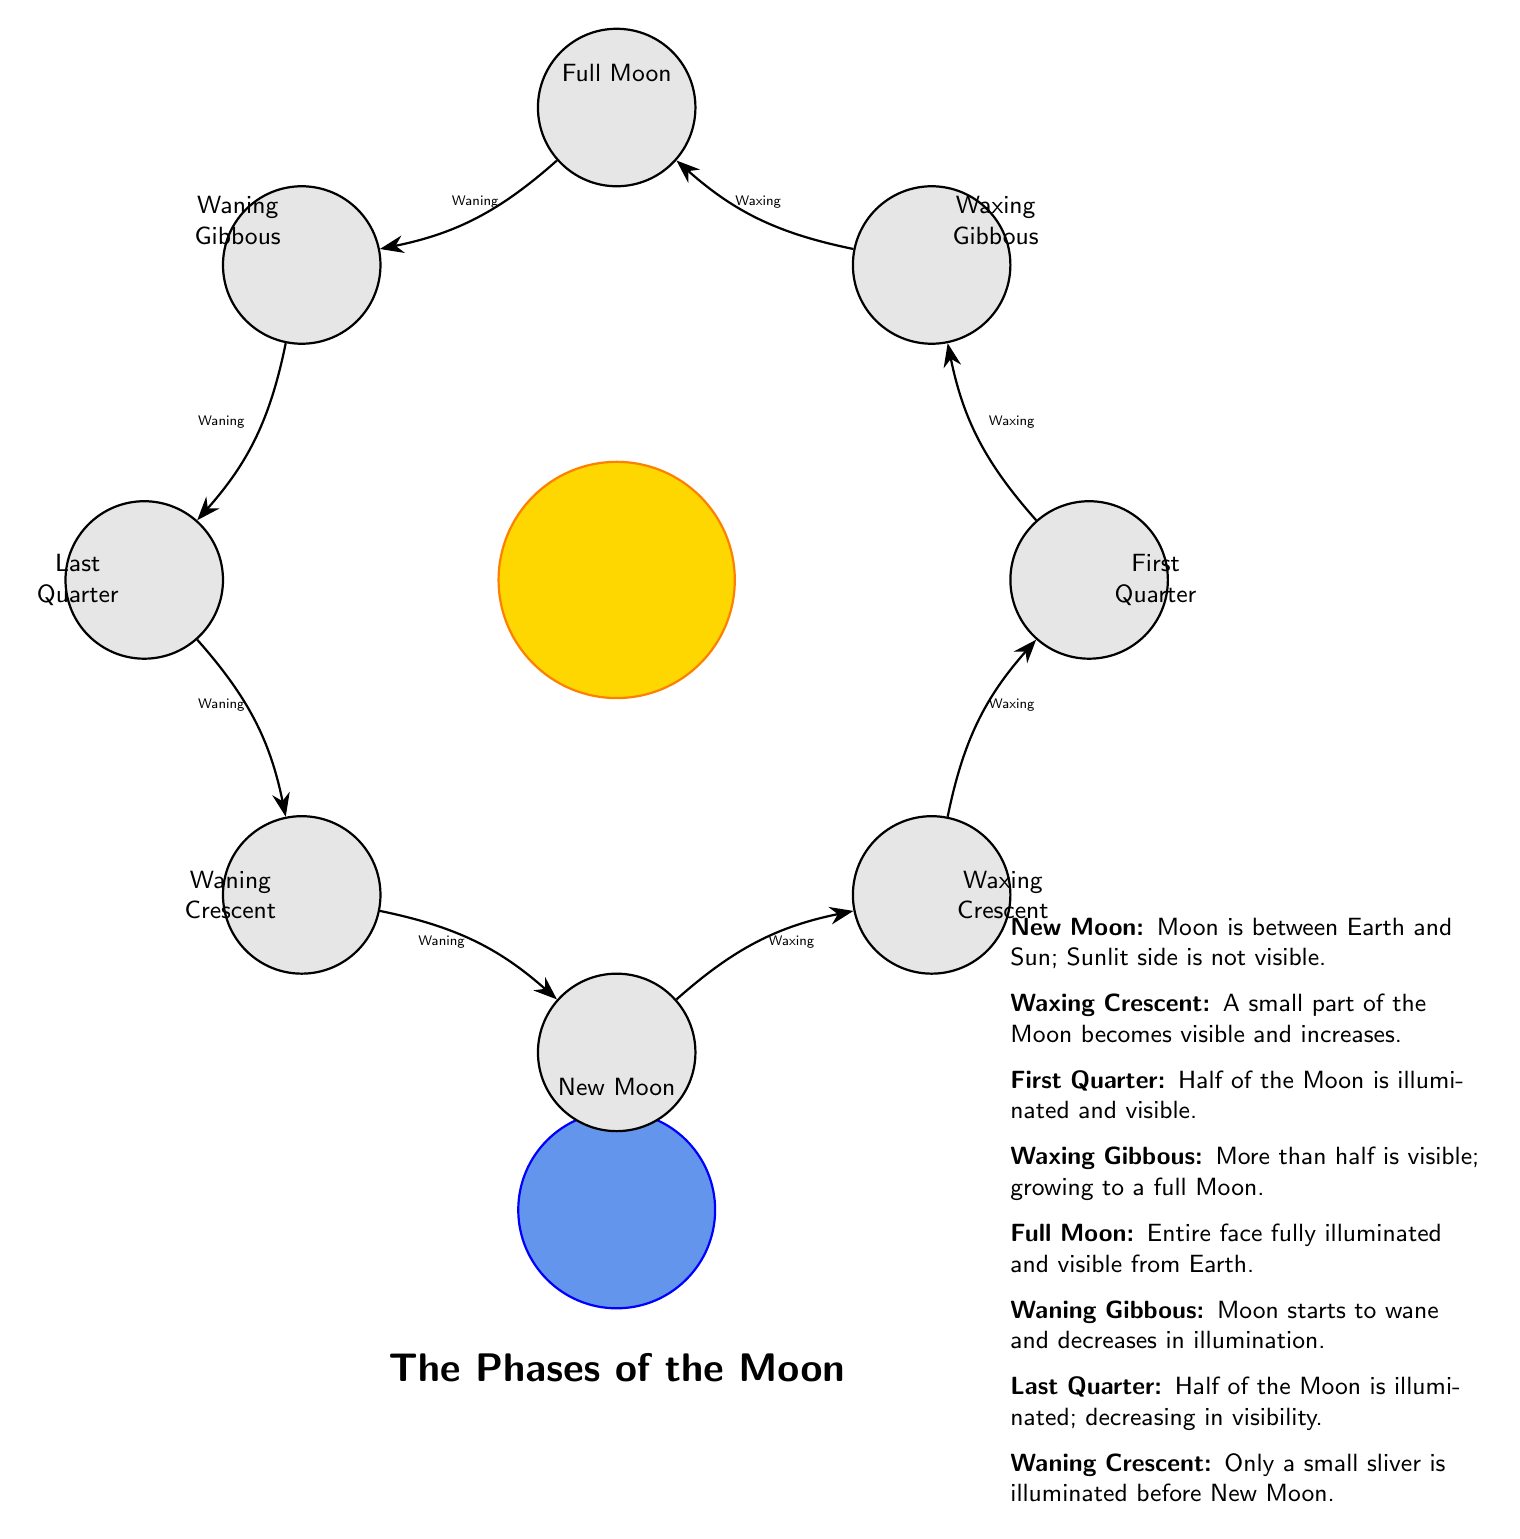What is the phase of the moon that directly follows the New Moon? The diagram shows the arrows indicating the flow from New Moon to Waxing Crescent, meaning the next phase is Waxing Crescent.
Answer: Waxing Crescent How many total phases of the moon are depicted in the diagram? Counting the circles labeled from New Moon to Waning Crescent yields a total of eight distinct phases.
Answer: 8 Which phase of the moon is fully illuminated? The diagram indicates that the Full Moon phase is represented with the label that signifies complete illumination.
Answer: Full Moon What phase occurs after the First Quarter? According to the arrows in the diagram, moving from First Quarter leads to the Waxing Gibbous phase, which is the next in the sequence.
Answer: Waxing Gibbous In which phase does the moon start to wane after the Full Moon? The diagram flows from the Full Moon to the Waning Gibbous phase next, indicating that this is the first phase where waning begins.
Answer: Waning Gibbous What type of moon phase is represented after the Last Quarter? Following the Last Quarter, the diagram leads to the Waning Crescent phase, which is the next phase illustrated.
Answer: Waning Crescent Which phase is characterized by having half of the moon illuminated? The diagram labels the First Quarter phase explicitly, showing that during this phase, half of the moon is visible and illuminated.
Answer: First Quarter What is the relationship between Waxing Gibbous and Waning Gibbous? The diagram shows that Waxing Gibbous comes before Waning Gibbous in the lunar cycle, indicating they are sequential phases with the latter representing a decrease in illumination.
Answer: Sequential phases 